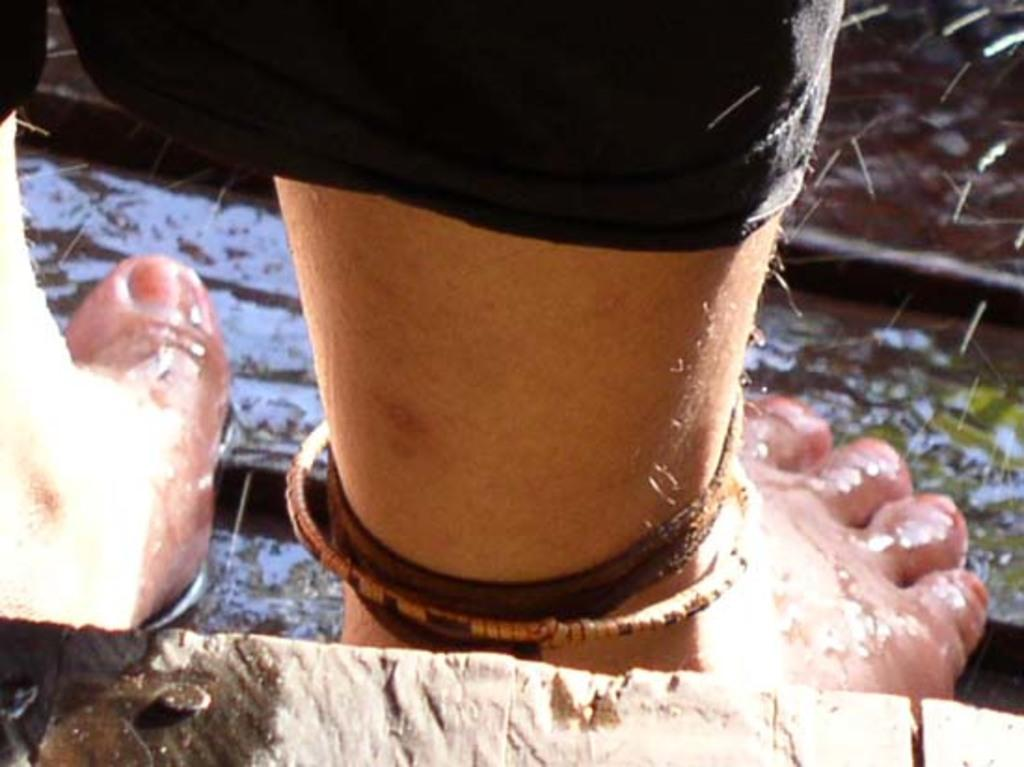What part of a person can be seen in the image? There are legs of a person in the image. What natural element is visible in the image? There is water visible in the image. What type of field is visible in the image? There is no field visible in the image; only legs and water are present. 